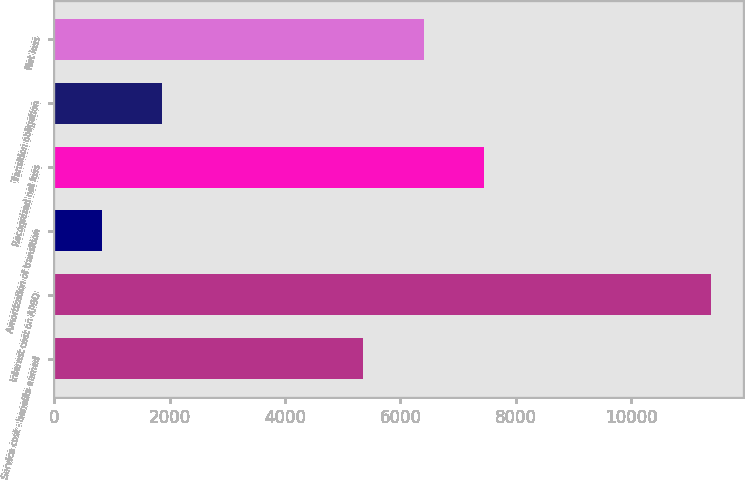Convert chart. <chart><loc_0><loc_0><loc_500><loc_500><bar_chart><fcel>Service cost - benefits earned<fcel>Interest cost on APBO<fcel>Amortization of transition<fcel>Recognized net loss<fcel>Transition obligation<fcel>Net loss<nl><fcel>5346<fcel>11374<fcel>821<fcel>7456.6<fcel>1876.3<fcel>6401.3<nl></chart> 